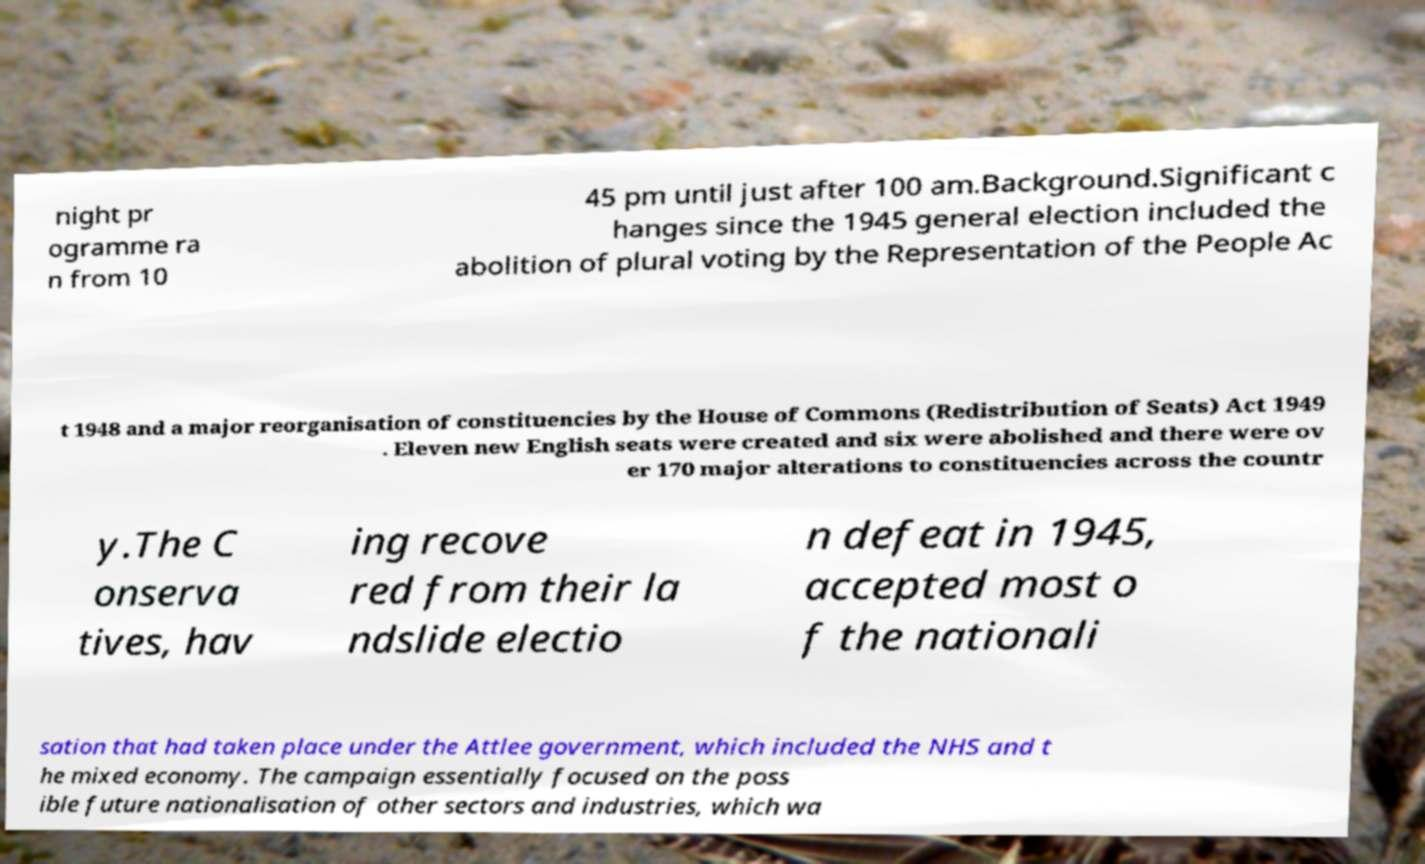Please identify and transcribe the text found in this image. night pr ogramme ra n from 10 45 pm until just after 100 am.Background.Significant c hanges since the 1945 general election included the abolition of plural voting by the Representation of the People Ac t 1948 and a major reorganisation of constituencies by the House of Commons (Redistribution of Seats) Act 1949 . Eleven new English seats were created and six were abolished and there were ov er 170 major alterations to constituencies across the countr y.The C onserva tives, hav ing recove red from their la ndslide electio n defeat in 1945, accepted most o f the nationali sation that had taken place under the Attlee government, which included the NHS and t he mixed economy. The campaign essentially focused on the poss ible future nationalisation of other sectors and industries, which wa 